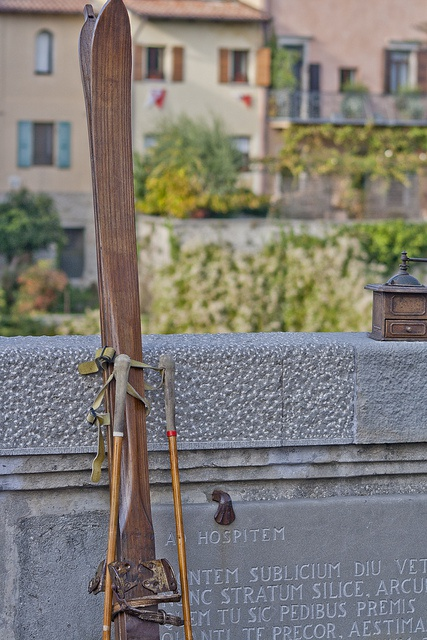Describe the objects in this image and their specific colors. I can see skis in gray, darkgray, and maroon tones in this image. 